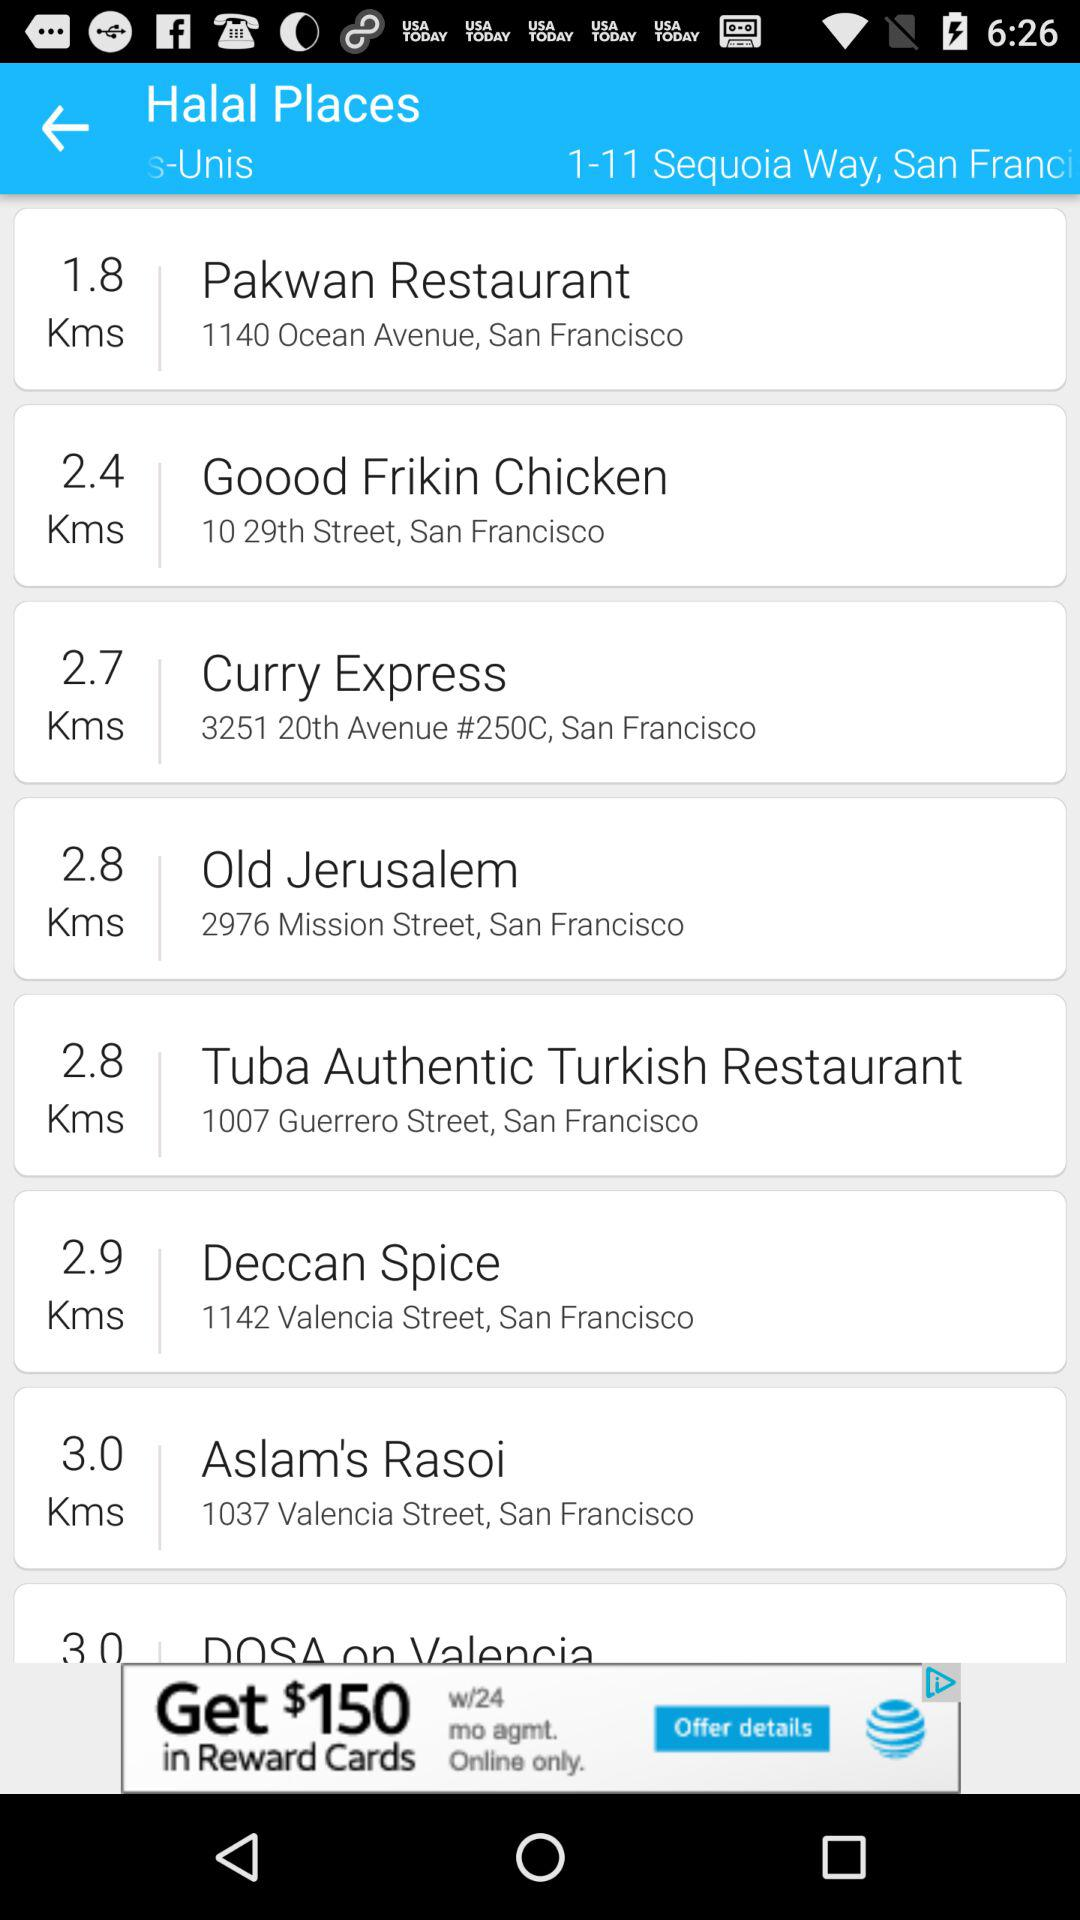What is the nearest place from 1-11 sequoia way, San Francisco?
When the provided information is insufficient, respond with <no answer>. <no answer> 